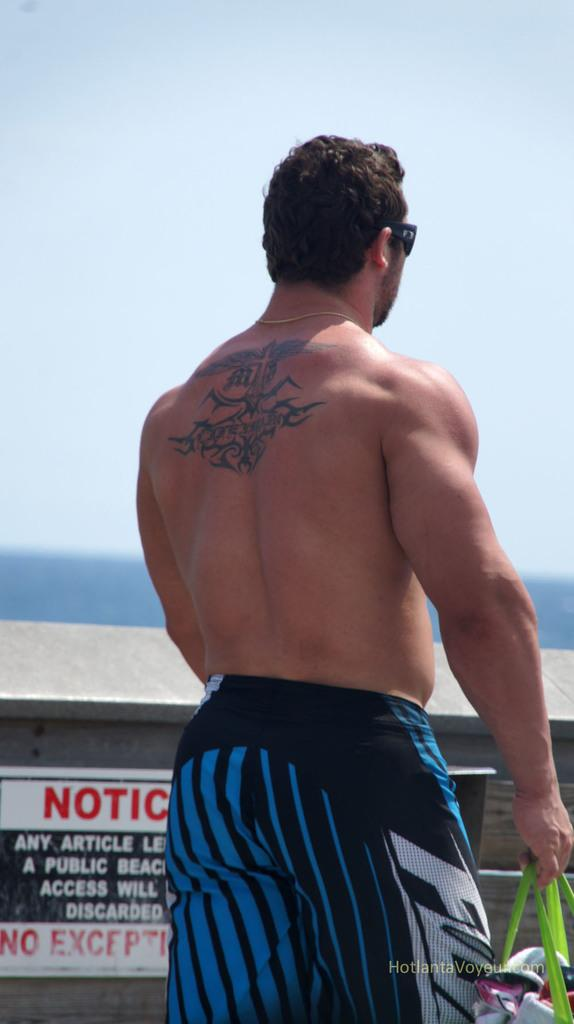<image>
Relay a brief, clear account of the picture shown. shirtless man with back tattoo in front of a notice sign on the fence 